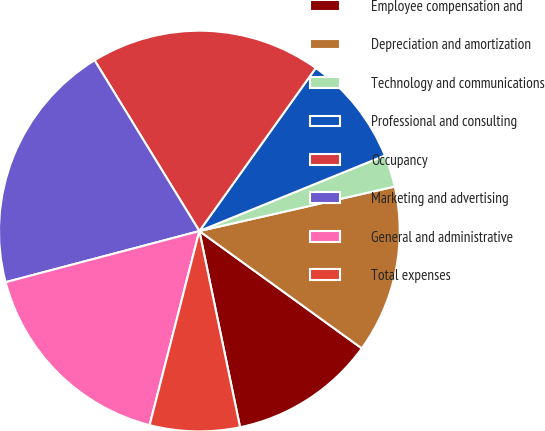Convert chart to OTSL. <chart><loc_0><loc_0><loc_500><loc_500><pie_chart><fcel>Employee compensation and<fcel>Depreciation and amortization<fcel>Technology and communications<fcel>Professional and consulting<fcel>Occupancy<fcel>Marketing and advertising<fcel>General and administrative<fcel>Total expenses<nl><fcel>11.79%<fcel>13.52%<fcel>2.59%<fcel>8.98%<fcel>18.63%<fcel>20.35%<fcel>16.9%<fcel>7.25%<nl></chart> 